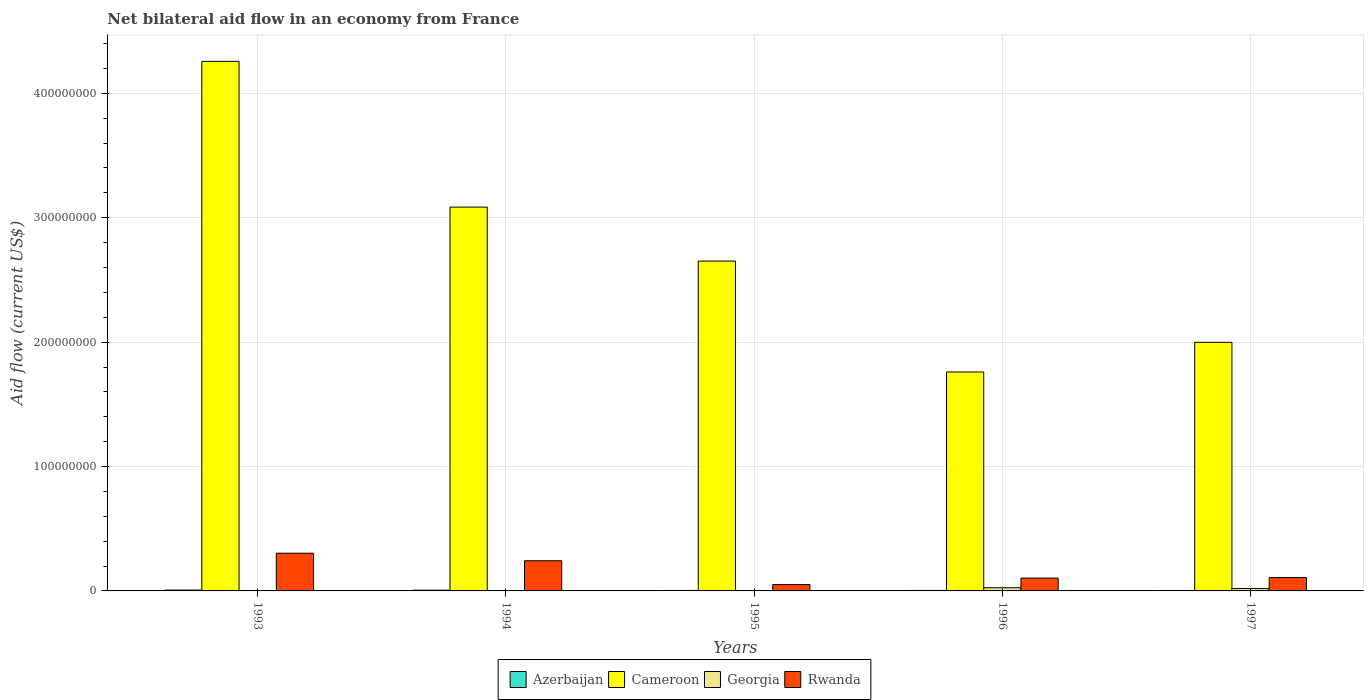How many different coloured bars are there?
Make the answer very short. 4. How many groups of bars are there?
Give a very brief answer. 5. Are the number of bars per tick equal to the number of legend labels?
Offer a very short reply. Yes. Are the number of bars on each tick of the X-axis equal?
Offer a terse response. Yes. How many bars are there on the 1st tick from the right?
Ensure brevity in your answer.  4. What is the net bilateral aid flow in Cameroon in 1995?
Make the answer very short. 2.65e+08. Across all years, what is the maximum net bilateral aid flow in Azerbaijan?
Your response must be concise. 6.80e+05. Across all years, what is the minimum net bilateral aid flow in Rwanda?
Your answer should be very brief. 5.10e+06. In which year was the net bilateral aid flow in Rwanda maximum?
Your answer should be compact. 1993. In which year was the net bilateral aid flow in Rwanda minimum?
Give a very brief answer. 1995. What is the total net bilateral aid flow in Rwanda in the graph?
Provide a succinct answer. 8.08e+07. What is the difference between the net bilateral aid flow in Rwanda in 1994 and that in 1996?
Give a very brief answer. 1.39e+07. What is the difference between the net bilateral aid flow in Azerbaijan in 1997 and the net bilateral aid flow in Cameroon in 1995?
Keep it short and to the point. -2.65e+08. What is the average net bilateral aid flow in Rwanda per year?
Give a very brief answer. 1.62e+07. In the year 1997, what is the difference between the net bilateral aid flow in Rwanda and net bilateral aid flow in Georgia?
Keep it short and to the point. 8.79e+06. What is the ratio of the net bilateral aid flow in Azerbaijan in 1993 to that in 1994?
Offer a very short reply. 1.11. What is the difference between the highest and the second highest net bilateral aid flow in Rwanda?
Offer a very short reply. 6.06e+06. What is the difference between the highest and the lowest net bilateral aid flow in Azerbaijan?
Keep it short and to the point. 3.20e+05. Is the sum of the net bilateral aid flow in Georgia in 1993 and 1995 greater than the maximum net bilateral aid flow in Cameroon across all years?
Provide a succinct answer. No. Is it the case that in every year, the sum of the net bilateral aid flow in Cameroon and net bilateral aid flow in Azerbaijan is greater than the sum of net bilateral aid flow in Rwanda and net bilateral aid flow in Georgia?
Your response must be concise. Yes. What does the 1st bar from the left in 1996 represents?
Your response must be concise. Azerbaijan. What does the 3rd bar from the right in 1995 represents?
Your response must be concise. Cameroon. Is it the case that in every year, the sum of the net bilateral aid flow in Georgia and net bilateral aid flow in Azerbaijan is greater than the net bilateral aid flow in Cameroon?
Offer a terse response. No. Does the graph contain any zero values?
Offer a very short reply. No. How many legend labels are there?
Your answer should be compact. 4. What is the title of the graph?
Make the answer very short. Net bilateral aid flow in an economy from France. Does "Estonia" appear as one of the legend labels in the graph?
Give a very brief answer. No. What is the label or title of the X-axis?
Give a very brief answer. Years. What is the Aid flow (current US$) in Azerbaijan in 1993?
Your response must be concise. 6.80e+05. What is the Aid flow (current US$) in Cameroon in 1993?
Provide a succinct answer. 4.26e+08. What is the Aid flow (current US$) of Georgia in 1993?
Keep it short and to the point. 2.40e+05. What is the Aid flow (current US$) of Rwanda in 1993?
Offer a terse response. 3.03e+07. What is the Aid flow (current US$) of Azerbaijan in 1994?
Make the answer very short. 6.10e+05. What is the Aid flow (current US$) of Cameroon in 1994?
Provide a succinct answer. 3.09e+08. What is the Aid flow (current US$) of Georgia in 1994?
Your response must be concise. 2.50e+05. What is the Aid flow (current US$) in Rwanda in 1994?
Offer a terse response. 2.43e+07. What is the Aid flow (current US$) in Cameroon in 1995?
Make the answer very short. 2.65e+08. What is the Aid flow (current US$) in Georgia in 1995?
Provide a succinct answer. 1.80e+05. What is the Aid flow (current US$) in Rwanda in 1995?
Offer a very short reply. 5.10e+06. What is the Aid flow (current US$) of Azerbaijan in 1996?
Offer a terse response. 4.10e+05. What is the Aid flow (current US$) in Cameroon in 1996?
Offer a very short reply. 1.76e+08. What is the Aid flow (current US$) of Georgia in 1996?
Provide a short and direct response. 2.57e+06. What is the Aid flow (current US$) in Rwanda in 1996?
Provide a succinct answer. 1.03e+07. What is the Aid flow (current US$) of Azerbaijan in 1997?
Keep it short and to the point. 3.60e+05. What is the Aid flow (current US$) of Cameroon in 1997?
Make the answer very short. 2.00e+08. What is the Aid flow (current US$) in Georgia in 1997?
Your response must be concise. 1.95e+06. What is the Aid flow (current US$) of Rwanda in 1997?
Offer a terse response. 1.07e+07. Across all years, what is the maximum Aid flow (current US$) in Azerbaijan?
Offer a very short reply. 6.80e+05. Across all years, what is the maximum Aid flow (current US$) in Cameroon?
Ensure brevity in your answer.  4.26e+08. Across all years, what is the maximum Aid flow (current US$) in Georgia?
Give a very brief answer. 2.57e+06. Across all years, what is the maximum Aid flow (current US$) of Rwanda?
Keep it short and to the point. 3.03e+07. Across all years, what is the minimum Aid flow (current US$) of Azerbaijan?
Offer a terse response. 3.60e+05. Across all years, what is the minimum Aid flow (current US$) of Cameroon?
Offer a terse response. 1.76e+08. Across all years, what is the minimum Aid flow (current US$) of Georgia?
Provide a short and direct response. 1.80e+05. Across all years, what is the minimum Aid flow (current US$) of Rwanda?
Make the answer very short. 5.10e+06. What is the total Aid flow (current US$) of Azerbaijan in the graph?
Offer a terse response. 2.43e+06. What is the total Aid flow (current US$) of Cameroon in the graph?
Your answer should be very brief. 1.38e+09. What is the total Aid flow (current US$) of Georgia in the graph?
Your response must be concise. 5.19e+06. What is the total Aid flow (current US$) of Rwanda in the graph?
Keep it short and to the point. 8.08e+07. What is the difference between the Aid flow (current US$) in Cameroon in 1993 and that in 1994?
Your answer should be very brief. 1.17e+08. What is the difference between the Aid flow (current US$) in Georgia in 1993 and that in 1994?
Give a very brief answer. -10000. What is the difference between the Aid flow (current US$) of Rwanda in 1993 and that in 1994?
Offer a terse response. 6.06e+06. What is the difference between the Aid flow (current US$) of Azerbaijan in 1993 and that in 1995?
Provide a short and direct response. 3.10e+05. What is the difference between the Aid flow (current US$) of Cameroon in 1993 and that in 1995?
Make the answer very short. 1.61e+08. What is the difference between the Aid flow (current US$) of Georgia in 1993 and that in 1995?
Provide a short and direct response. 6.00e+04. What is the difference between the Aid flow (current US$) in Rwanda in 1993 and that in 1995?
Give a very brief answer. 2.52e+07. What is the difference between the Aid flow (current US$) in Cameroon in 1993 and that in 1996?
Ensure brevity in your answer.  2.50e+08. What is the difference between the Aid flow (current US$) in Georgia in 1993 and that in 1996?
Give a very brief answer. -2.33e+06. What is the difference between the Aid flow (current US$) of Rwanda in 1993 and that in 1996?
Keep it short and to the point. 2.00e+07. What is the difference between the Aid flow (current US$) of Cameroon in 1993 and that in 1997?
Offer a terse response. 2.26e+08. What is the difference between the Aid flow (current US$) of Georgia in 1993 and that in 1997?
Offer a very short reply. -1.71e+06. What is the difference between the Aid flow (current US$) of Rwanda in 1993 and that in 1997?
Provide a short and direct response. 1.96e+07. What is the difference between the Aid flow (current US$) of Cameroon in 1994 and that in 1995?
Your answer should be very brief. 4.34e+07. What is the difference between the Aid flow (current US$) of Georgia in 1994 and that in 1995?
Give a very brief answer. 7.00e+04. What is the difference between the Aid flow (current US$) in Rwanda in 1994 and that in 1995?
Offer a very short reply. 1.92e+07. What is the difference between the Aid flow (current US$) in Cameroon in 1994 and that in 1996?
Ensure brevity in your answer.  1.33e+08. What is the difference between the Aid flow (current US$) in Georgia in 1994 and that in 1996?
Offer a terse response. -2.32e+06. What is the difference between the Aid flow (current US$) in Rwanda in 1994 and that in 1996?
Your answer should be very brief. 1.39e+07. What is the difference between the Aid flow (current US$) in Cameroon in 1994 and that in 1997?
Provide a short and direct response. 1.09e+08. What is the difference between the Aid flow (current US$) of Georgia in 1994 and that in 1997?
Keep it short and to the point. -1.70e+06. What is the difference between the Aid flow (current US$) in Rwanda in 1994 and that in 1997?
Keep it short and to the point. 1.35e+07. What is the difference between the Aid flow (current US$) in Azerbaijan in 1995 and that in 1996?
Make the answer very short. -4.00e+04. What is the difference between the Aid flow (current US$) of Cameroon in 1995 and that in 1996?
Offer a very short reply. 8.92e+07. What is the difference between the Aid flow (current US$) of Georgia in 1995 and that in 1996?
Provide a short and direct response. -2.39e+06. What is the difference between the Aid flow (current US$) in Rwanda in 1995 and that in 1996?
Your response must be concise. -5.23e+06. What is the difference between the Aid flow (current US$) of Cameroon in 1995 and that in 1997?
Ensure brevity in your answer.  6.53e+07. What is the difference between the Aid flow (current US$) of Georgia in 1995 and that in 1997?
Your answer should be very brief. -1.77e+06. What is the difference between the Aid flow (current US$) in Rwanda in 1995 and that in 1997?
Offer a terse response. -5.64e+06. What is the difference between the Aid flow (current US$) in Cameroon in 1996 and that in 1997?
Your answer should be very brief. -2.38e+07. What is the difference between the Aid flow (current US$) of Georgia in 1996 and that in 1997?
Provide a succinct answer. 6.20e+05. What is the difference between the Aid flow (current US$) in Rwanda in 1996 and that in 1997?
Make the answer very short. -4.10e+05. What is the difference between the Aid flow (current US$) of Azerbaijan in 1993 and the Aid flow (current US$) of Cameroon in 1994?
Offer a very short reply. -3.08e+08. What is the difference between the Aid flow (current US$) in Azerbaijan in 1993 and the Aid flow (current US$) in Rwanda in 1994?
Provide a succinct answer. -2.36e+07. What is the difference between the Aid flow (current US$) of Cameroon in 1993 and the Aid flow (current US$) of Georgia in 1994?
Your response must be concise. 4.25e+08. What is the difference between the Aid flow (current US$) in Cameroon in 1993 and the Aid flow (current US$) in Rwanda in 1994?
Keep it short and to the point. 4.01e+08. What is the difference between the Aid flow (current US$) of Georgia in 1993 and the Aid flow (current US$) of Rwanda in 1994?
Give a very brief answer. -2.40e+07. What is the difference between the Aid flow (current US$) of Azerbaijan in 1993 and the Aid flow (current US$) of Cameroon in 1995?
Your answer should be compact. -2.64e+08. What is the difference between the Aid flow (current US$) in Azerbaijan in 1993 and the Aid flow (current US$) in Rwanda in 1995?
Provide a succinct answer. -4.42e+06. What is the difference between the Aid flow (current US$) in Cameroon in 1993 and the Aid flow (current US$) in Georgia in 1995?
Ensure brevity in your answer.  4.26e+08. What is the difference between the Aid flow (current US$) of Cameroon in 1993 and the Aid flow (current US$) of Rwanda in 1995?
Give a very brief answer. 4.21e+08. What is the difference between the Aid flow (current US$) of Georgia in 1993 and the Aid flow (current US$) of Rwanda in 1995?
Make the answer very short. -4.86e+06. What is the difference between the Aid flow (current US$) of Azerbaijan in 1993 and the Aid flow (current US$) of Cameroon in 1996?
Make the answer very short. -1.75e+08. What is the difference between the Aid flow (current US$) in Azerbaijan in 1993 and the Aid flow (current US$) in Georgia in 1996?
Your response must be concise. -1.89e+06. What is the difference between the Aid flow (current US$) of Azerbaijan in 1993 and the Aid flow (current US$) of Rwanda in 1996?
Your answer should be very brief. -9.65e+06. What is the difference between the Aid flow (current US$) in Cameroon in 1993 and the Aid flow (current US$) in Georgia in 1996?
Keep it short and to the point. 4.23e+08. What is the difference between the Aid flow (current US$) of Cameroon in 1993 and the Aid flow (current US$) of Rwanda in 1996?
Offer a terse response. 4.15e+08. What is the difference between the Aid flow (current US$) in Georgia in 1993 and the Aid flow (current US$) in Rwanda in 1996?
Provide a succinct answer. -1.01e+07. What is the difference between the Aid flow (current US$) of Azerbaijan in 1993 and the Aid flow (current US$) of Cameroon in 1997?
Your answer should be very brief. -1.99e+08. What is the difference between the Aid flow (current US$) in Azerbaijan in 1993 and the Aid flow (current US$) in Georgia in 1997?
Offer a very short reply. -1.27e+06. What is the difference between the Aid flow (current US$) in Azerbaijan in 1993 and the Aid flow (current US$) in Rwanda in 1997?
Provide a short and direct response. -1.01e+07. What is the difference between the Aid flow (current US$) in Cameroon in 1993 and the Aid flow (current US$) in Georgia in 1997?
Offer a terse response. 4.24e+08. What is the difference between the Aid flow (current US$) of Cameroon in 1993 and the Aid flow (current US$) of Rwanda in 1997?
Keep it short and to the point. 4.15e+08. What is the difference between the Aid flow (current US$) in Georgia in 1993 and the Aid flow (current US$) in Rwanda in 1997?
Your answer should be very brief. -1.05e+07. What is the difference between the Aid flow (current US$) of Azerbaijan in 1994 and the Aid flow (current US$) of Cameroon in 1995?
Give a very brief answer. -2.65e+08. What is the difference between the Aid flow (current US$) of Azerbaijan in 1994 and the Aid flow (current US$) of Georgia in 1995?
Ensure brevity in your answer.  4.30e+05. What is the difference between the Aid flow (current US$) in Azerbaijan in 1994 and the Aid flow (current US$) in Rwanda in 1995?
Your answer should be very brief. -4.49e+06. What is the difference between the Aid flow (current US$) in Cameroon in 1994 and the Aid flow (current US$) in Georgia in 1995?
Your response must be concise. 3.08e+08. What is the difference between the Aid flow (current US$) of Cameroon in 1994 and the Aid flow (current US$) of Rwanda in 1995?
Keep it short and to the point. 3.03e+08. What is the difference between the Aid flow (current US$) in Georgia in 1994 and the Aid flow (current US$) in Rwanda in 1995?
Make the answer very short. -4.85e+06. What is the difference between the Aid flow (current US$) of Azerbaijan in 1994 and the Aid flow (current US$) of Cameroon in 1996?
Make the answer very short. -1.75e+08. What is the difference between the Aid flow (current US$) of Azerbaijan in 1994 and the Aid flow (current US$) of Georgia in 1996?
Make the answer very short. -1.96e+06. What is the difference between the Aid flow (current US$) of Azerbaijan in 1994 and the Aid flow (current US$) of Rwanda in 1996?
Provide a succinct answer. -9.72e+06. What is the difference between the Aid flow (current US$) in Cameroon in 1994 and the Aid flow (current US$) in Georgia in 1996?
Provide a short and direct response. 3.06e+08. What is the difference between the Aid flow (current US$) of Cameroon in 1994 and the Aid flow (current US$) of Rwanda in 1996?
Ensure brevity in your answer.  2.98e+08. What is the difference between the Aid flow (current US$) in Georgia in 1994 and the Aid flow (current US$) in Rwanda in 1996?
Give a very brief answer. -1.01e+07. What is the difference between the Aid flow (current US$) of Azerbaijan in 1994 and the Aid flow (current US$) of Cameroon in 1997?
Your answer should be compact. -1.99e+08. What is the difference between the Aid flow (current US$) in Azerbaijan in 1994 and the Aid flow (current US$) in Georgia in 1997?
Your response must be concise. -1.34e+06. What is the difference between the Aid flow (current US$) in Azerbaijan in 1994 and the Aid flow (current US$) in Rwanda in 1997?
Provide a short and direct response. -1.01e+07. What is the difference between the Aid flow (current US$) in Cameroon in 1994 and the Aid flow (current US$) in Georgia in 1997?
Give a very brief answer. 3.07e+08. What is the difference between the Aid flow (current US$) in Cameroon in 1994 and the Aid flow (current US$) in Rwanda in 1997?
Your response must be concise. 2.98e+08. What is the difference between the Aid flow (current US$) in Georgia in 1994 and the Aid flow (current US$) in Rwanda in 1997?
Your answer should be compact. -1.05e+07. What is the difference between the Aid flow (current US$) of Azerbaijan in 1995 and the Aid flow (current US$) of Cameroon in 1996?
Your answer should be very brief. -1.76e+08. What is the difference between the Aid flow (current US$) in Azerbaijan in 1995 and the Aid flow (current US$) in Georgia in 1996?
Your answer should be compact. -2.20e+06. What is the difference between the Aid flow (current US$) of Azerbaijan in 1995 and the Aid flow (current US$) of Rwanda in 1996?
Your answer should be compact. -9.96e+06. What is the difference between the Aid flow (current US$) in Cameroon in 1995 and the Aid flow (current US$) in Georgia in 1996?
Ensure brevity in your answer.  2.63e+08. What is the difference between the Aid flow (current US$) in Cameroon in 1995 and the Aid flow (current US$) in Rwanda in 1996?
Provide a short and direct response. 2.55e+08. What is the difference between the Aid flow (current US$) in Georgia in 1995 and the Aid flow (current US$) in Rwanda in 1996?
Offer a terse response. -1.02e+07. What is the difference between the Aid flow (current US$) in Azerbaijan in 1995 and the Aid flow (current US$) in Cameroon in 1997?
Your answer should be very brief. -1.99e+08. What is the difference between the Aid flow (current US$) of Azerbaijan in 1995 and the Aid flow (current US$) of Georgia in 1997?
Provide a short and direct response. -1.58e+06. What is the difference between the Aid flow (current US$) of Azerbaijan in 1995 and the Aid flow (current US$) of Rwanda in 1997?
Give a very brief answer. -1.04e+07. What is the difference between the Aid flow (current US$) in Cameroon in 1995 and the Aid flow (current US$) in Georgia in 1997?
Your response must be concise. 2.63e+08. What is the difference between the Aid flow (current US$) of Cameroon in 1995 and the Aid flow (current US$) of Rwanda in 1997?
Provide a succinct answer. 2.54e+08. What is the difference between the Aid flow (current US$) in Georgia in 1995 and the Aid flow (current US$) in Rwanda in 1997?
Offer a terse response. -1.06e+07. What is the difference between the Aid flow (current US$) in Azerbaijan in 1996 and the Aid flow (current US$) in Cameroon in 1997?
Your response must be concise. -1.99e+08. What is the difference between the Aid flow (current US$) of Azerbaijan in 1996 and the Aid flow (current US$) of Georgia in 1997?
Your response must be concise. -1.54e+06. What is the difference between the Aid flow (current US$) in Azerbaijan in 1996 and the Aid flow (current US$) in Rwanda in 1997?
Keep it short and to the point. -1.03e+07. What is the difference between the Aid flow (current US$) in Cameroon in 1996 and the Aid flow (current US$) in Georgia in 1997?
Your answer should be very brief. 1.74e+08. What is the difference between the Aid flow (current US$) of Cameroon in 1996 and the Aid flow (current US$) of Rwanda in 1997?
Make the answer very short. 1.65e+08. What is the difference between the Aid flow (current US$) of Georgia in 1996 and the Aid flow (current US$) of Rwanda in 1997?
Ensure brevity in your answer.  -8.17e+06. What is the average Aid flow (current US$) of Azerbaijan per year?
Your answer should be compact. 4.86e+05. What is the average Aid flow (current US$) in Cameroon per year?
Your answer should be very brief. 2.75e+08. What is the average Aid flow (current US$) of Georgia per year?
Offer a very short reply. 1.04e+06. What is the average Aid flow (current US$) of Rwanda per year?
Your answer should be compact. 1.62e+07. In the year 1993, what is the difference between the Aid flow (current US$) in Azerbaijan and Aid flow (current US$) in Cameroon?
Your answer should be compact. -4.25e+08. In the year 1993, what is the difference between the Aid flow (current US$) of Azerbaijan and Aid flow (current US$) of Rwanda?
Ensure brevity in your answer.  -2.96e+07. In the year 1993, what is the difference between the Aid flow (current US$) of Cameroon and Aid flow (current US$) of Georgia?
Give a very brief answer. 4.25e+08. In the year 1993, what is the difference between the Aid flow (current US$) of Cameroon and Aid flow (current US$) of Rwanda?
Your answer should be very brief. 3.95e+08. In the year 1993, what is the difference between the Aid flow (current US$) of Georgia and Aid flow (current US$) of Rwanda?
Your response must be concise. -3.01e+07. In the year 1994, what is the difference between the Aid flow (current US$) in Azerbaijan and Aid flow (current US$) in Cameroon?
Your response must be concise. -3.08e+08. In the year 1994, what is the difference between the Aid flow (current US$) of Azerbaijan and Aid flow (current US$) of Rwanda?
Ensure brevity in your answer.  -2.36e+07. In the year 1994, what is the difference between the Aid flow (current US$) of Cameroon and Aid flow (current US$) of Georgia?
Offer a terse response. 3.08e+08. In the year 1994, what is the difference between the Aid flow (current US$) of Cameroon and Aid flow (current US$) of Rwanda?
Your response must be concise. 2.84e+08. In the year 1994, what is the difference between the Aid flow (current US$) in Georgia and Aid flow (current US$) in Rwanda?
Your response must be concise. -2.40e+07. In the year 1995, what is the difference between the Aid flow (current US$) in Azerbaijan and Aid flow (current US$) in Cameroon?
Your response must be concise. -2.65e+08. In the year 1995, what is the difference between the Aid flow (current US$) of Azerbaijan and Aid flow (current US$) of Georgia?
Your answer should be compact. 1.90e+05. In the year 1995, what is the difference between the Aid flow (current US$) in Azerbaijan and Aid flow (current US$) in Rwanda?
Give a very brief answer. -4.73e+06. In the year 1995, what is the difference between the Aid flow (current US$) in Cameroon and Aid flow (current US$) in Georgia?
Ensure brevity in your answer.  2.65e+08. In the year 1995, what is the difference between the Aid flow (current US$) in Cameroon and Aid flow (current US$) in Rwanda?
Your response must be concise. 2.60e+08. In the year 1995, what is the difference between the Aid flow (current US$) of Georgia and Aid flow (current US$) of Rwanda?
Offer a very short reply. -4.92e+06. In the year 1996, what is the difference between the Aid flow (current US$) of Azerbaijan and Aid flow (current US$) of Cameroon?
Offer a very short reply. -1.76e+08. In the year 1996, what is the difference between the Aid flow (current US$) in Azerbaijan and Aid flow (current US$) in Georgia?
Offer a terse response. -2.16e+06. In the year 1996, what is the difference between the Aid flow (current US$) of Azerbaijan and Aid flow (current US$) of Rwanda?
Give a very brief answer. -9.92e+06. In the year 1996, what is the difference between the Aid flow (current US$) of Cameroon and Aid flow (current US$) of Georgia?
Keep it short and to the point. 1.73e+08. In the year 1996, what is the difference between the Aid flow (current US$) of Cameroon and Aid flow (current US$) of Rwanda?
Your answer should be compact. 1.66e+08. In the year 1996, what is the difference between the Aid flow (current US$) in Georgia and Aid flow (current US$) in Rwanda?
Provide a succinct answer. -7.76e+06. In the year 1997, what is the difference between the Aid flow (current US$) of Azerbaijan and Aid flow (current US$) of Cameroon?
Your answer should be compact. -1.99e+08. In the year 1997, what is the difference between the Aid flow (current US$) in Azerbaijan and Aid flow (current US$) in Georgia?
Offer a very short reply. -1.59e+06. In the year 1997, what is the difference between the Aid flow (current US$) in Azerbaijan and Aid flow (current US$) in Rwanda?
Make the answer very short. -1.04e+07. In the year 1997, what is the difference between the Aid flow (current US$) in Cameroon and Aid flow (current US$) in Georgia?
Give a very brief answer. 1.98e+08. In the year 1997, what is the difference between the Aid flow (current US$) of Cameroon and Aid flow (current US$) of Rwanda?
Provide a succinct answer. 1.89e+08. In the year 1997, what is the difference between the Aid flow (current US$) in Georgia and Aid flow (current US$) in Rwanda?
Ensure brevity in your answer.  -8.79e+06. What is the ratio of the Aid flow (current US$) in Azerbaijan in 1993 to that in 1994?
Keep it short and to the point. 1.11. What is the ratio of the Aid flow (current US$) in Cameroon in 1993 to that in 1994?
Offer a very short reply. 1.38. What is the ratio of the Aid flow (current US$) in Georgia in 1993 to that in 1994?
Keep it short and to the point. 0.96. What is the ratio of the Aid flow (current US$) of Rwanda in 1993 to that in 1994?
Provide a short and direct response. 1.25. What is the ratio of the Aid flow (current US$) in Azerbaijan in 1993 to that in 1995?
Keep it short and to the point. 1.84. What is the ratio of the Aid flow (current US$) of Cameroon in 1993 to that in 1995?
Give a very brief answer. 1.61. What is the ratio of the Aid flow (current US$) of Rwanda in 1993 to that in 1995?
Your answer should be very brief. 5.95. What is the ratio of the Aid flow (current US$) of Azerbaijan in 1993 to that in 1996?
Your response must be concise. 1.66. What is the ratio of the Aid flow (current US$) in Cameroon in 1993 to that in 1996?
Offer a terse response. 2.42. What is the ratio of the Aid flow (current US$) of Georgia in 1993 to that in 1996?
Provide a succinct answer. 0.09. What is the ratio of the Aid flow (current US$) of Rwanda in 1993 to that in 1996?
Your response must be concise. 2.94. What is the ratio of the Aid flow (current US$) of Azerbaijan in 1993 to that in 1997?
Ensure brevity in your answer.  1.89. What is the ratio of the Aid flow (current US$) of Cameroon in 1993 to that in 1997?
Provide a succinct answer. 2.13. What is the ratio of the Aid flow (current US$) in Georgia in 1993 to that in 1997?
Give a very brief answer. 0.12. What is the ratio of the Aid flow (current US$) of Rwanda in 1993 to that in 1997?
Your response must be concise. 2.82. What is the ratio of the Aid flow (current US$) in Azerbaijan in 1994 to that in 1995?
Make the answer very short. 1.65. What is the ratio of the Aid flow (current US$) in Cameroon in 1994 to that in 1995?
Provide a short and direct response. 1.16. What is the ratio of the Aid flow (current US$) in Georgia in 1994 to that in 1995?
Your response must be concise. 1.39. What is the ratio of the Aid flow (current US$) in Rwanda in 1994 to that in 1995?
Keep it short and to the point. 4.76. What is the ratio of the Aid flow (current US$) of Azerbaijan in 1994 to that in 1996?
Offer a terse response. 1.49. What is the ratio of the Aid flow (current US$) in Cameroon in 1994 to that in 1996?
Your answer should be compact. 1.75. What is the ratio of the Aid flow (current US$) of Georgia in 1994 to that in 1996?
Your answer should be very brief. 0.1. What is the ratio of the Aid flow (current US$) of Rwanda in 1994 to that in 1996?
Give a very brief answer. 2.35. What is the ratio of the Aid flow (current US$) in Azerbaijan in 1994 to that in 1997?
Make the answer very short. 1.69. What is the ratio of the Aid flow (current US$) in Cameroon in 1994 to that in 1997?
Make the answer very short. 1.54. What is the ratio of the Aid flow (current US$) in Georgia in 1994 to that in 1997?
Make the answer very short. 0.13. What is the ratio of the Aid flow (current US$) of Rwanda in 1994 to that in 1997?
Provide a succinct answer. 2.26. What is the ratio of the Aid flow (current US$) of Azerbaijan in 1995 to that in 1996?
Offer a terse response. 0.9. What is the ratio of the Aid flow (current US$) of Cameroon in 1995 to that in 1996?
Make the answer very short. 1.51. What is the ratio of the Aid flow (current US$) of Georgia in 1995 to that in 1996?
Offer a very short reply. 0.07. What is the ratio of the Aid flow (current US$) of Rwanda in 1995 to that in 1996?
Make the answer very short. 0.49. What is the ratio of the Aid flow (current US$) of Azerbaijan in 1995 to that in 1997?
Keep it short and to the point. 1.03. What is the ratio of the Aid flow (current US$) in Cameroon in 1995 to that in 1997?
Offer a very short reply. 1.33. What is the ratio of the Aid flow (current US$) of Georgia in 1995 to that in 1997?
Make the answer very short. 0.09. What is the ratio of the Aid flow (current US$) in Rwanda in 1995 to that in 1997?
Offer a terse response. 0.47. What is the ratio of the Aid flow (current US$) of Azerbaijan in 1996 to that in 1997?
Keep it short and to the point. 1.14. What is the ratio of the Aid flow (current US$) in Cameroon in 1996 to that in 1997?
Provide a succinct answer. 0.88. What is the ratio of the Aid flow (current US$) of Georgia in 1996 to that in 1997?
Ensure brevity in your answer.  1.32. What is the ratio of the Aid flow (current US$) in Rwanda in 1996 to that in 1997?
Keep it short and to the point. 0.96. What is the difference between the highest and the second highest Aid flow (current US$) of Azerbaijan?
Give a very brief answer. 7.00e+04. What is the difference between the highest and the second highest Aid flow (current US$) of Cameroon?
Provide a short and direct response. 1.17e+08. What is the difference between the highest and the second highest Aid flow (current US$) of Georgia?
Ensure brevity in your answer.  6.20e+05. What is the difference between the highest and the second highest Aid flow (current US$) in Rwanda?
Provide a succinct answer. 6.06e+06. What is the difference between the highest and the lowest Aid flow (current US$) of Cameroon?
Provide a succinct answer. 2.50e+08. What is the difference between the highest and the lowest Aid flow (current US$) in Georgia?
Provide a short and direct response. 2.39e+06. What is the difference between the highest and the lowest Aid flow (current US$) of Rwanda?
Offer a very short reply. 2.52e+07. 